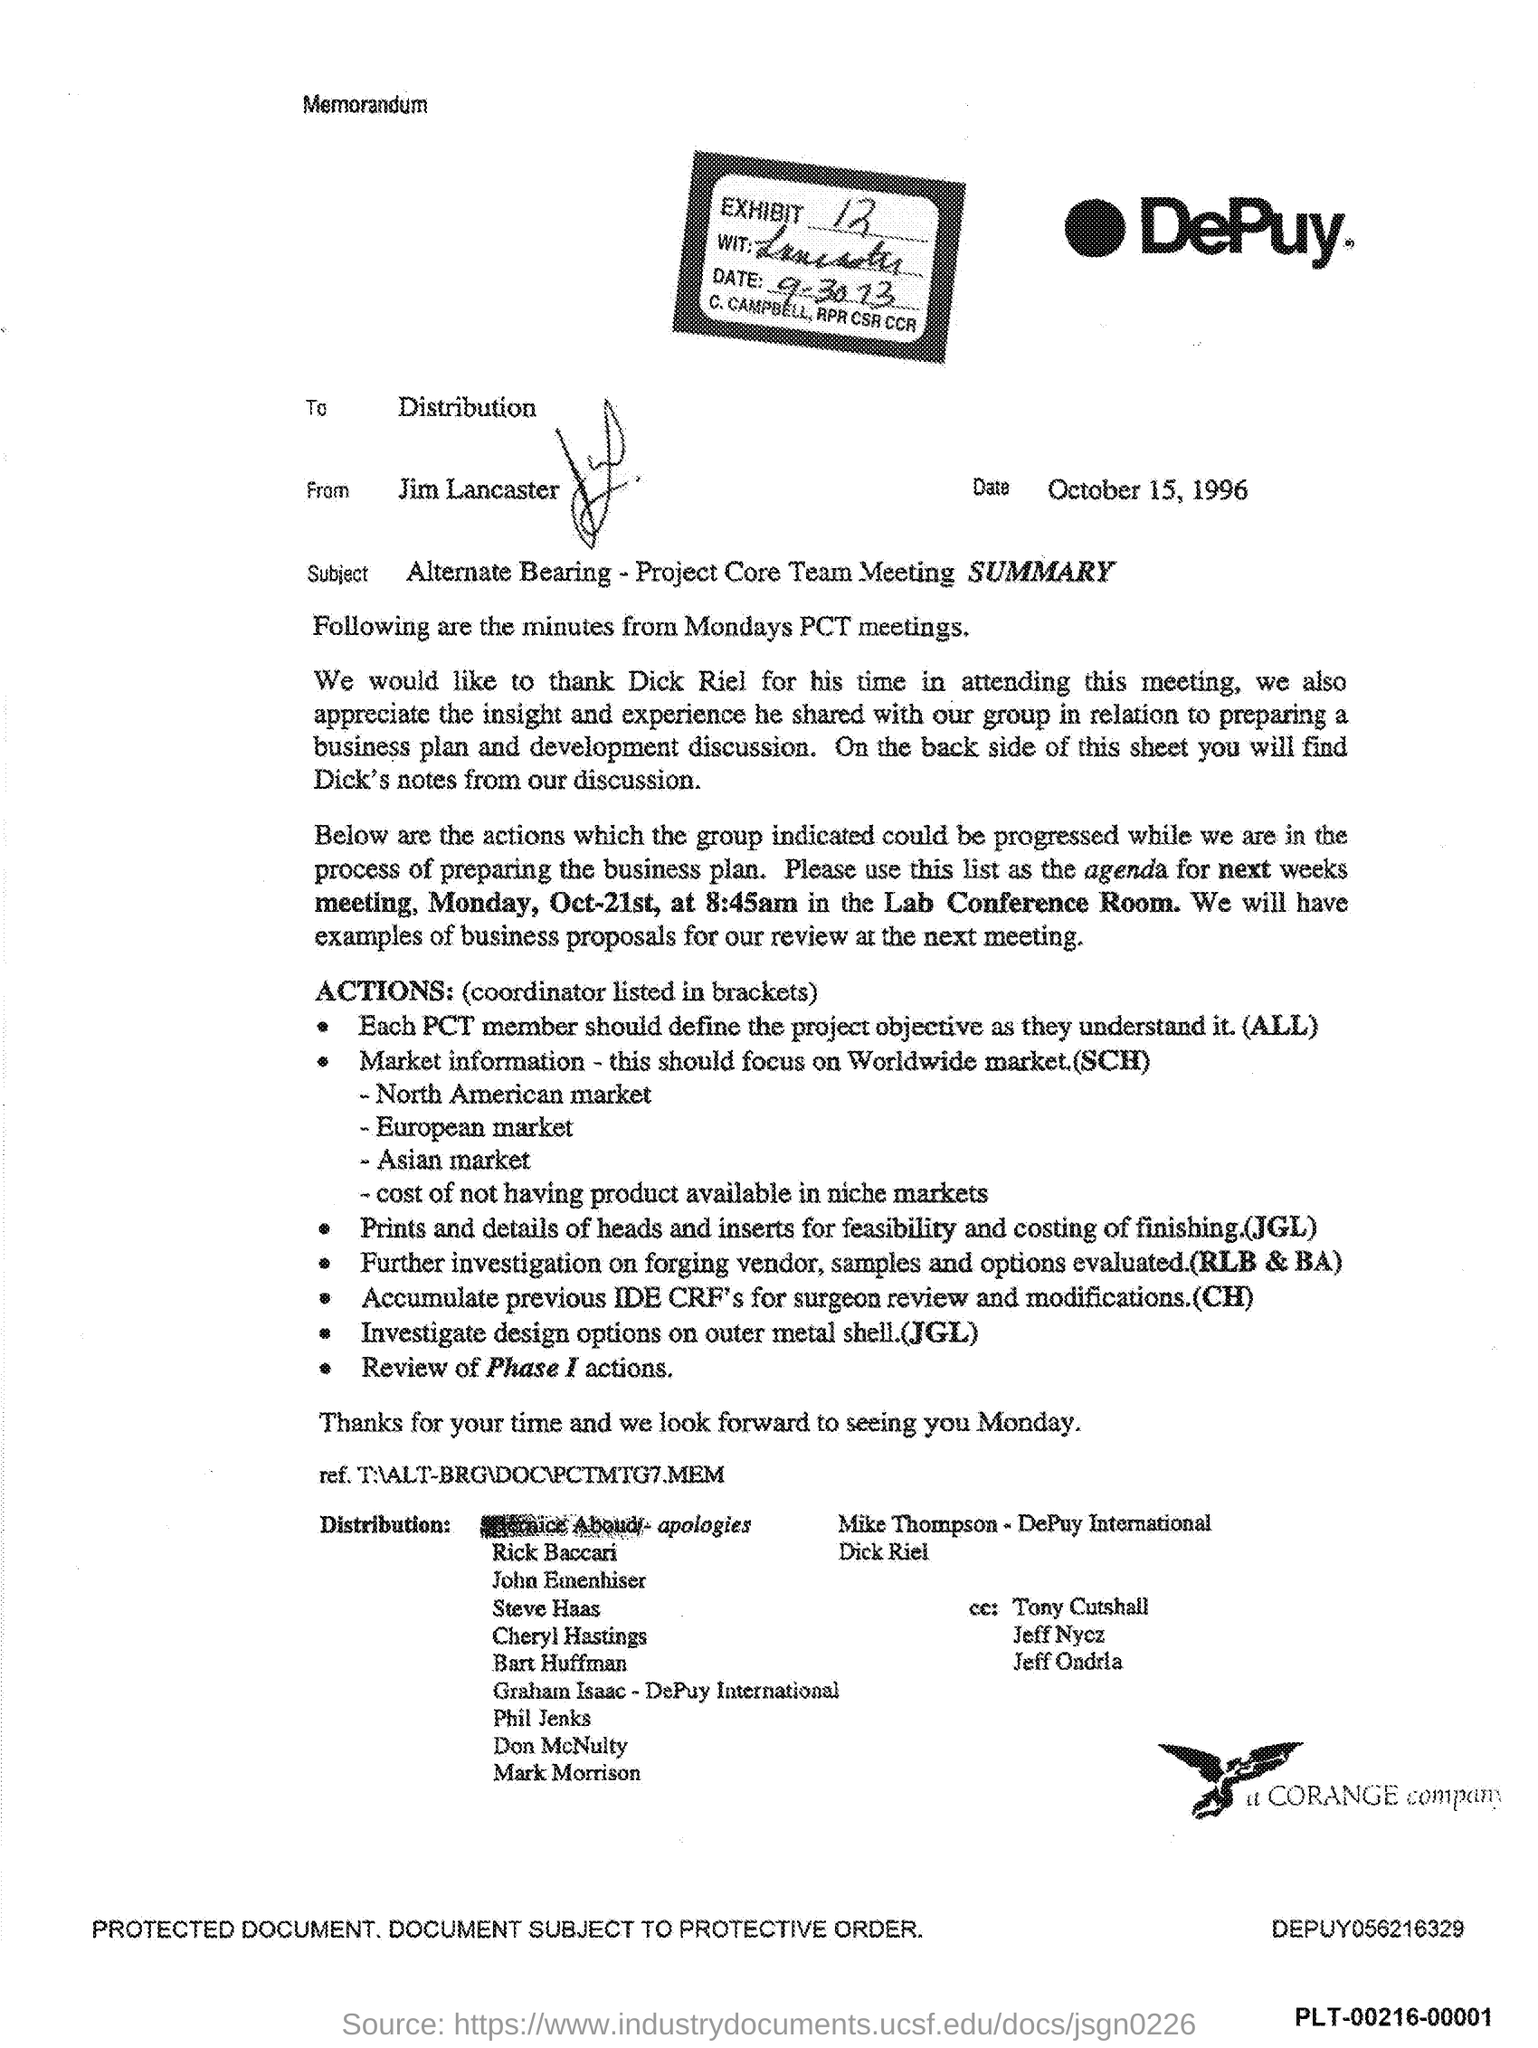Highlight a few significant elements in this photo. This memorandum concerns the subject of alternate bearing for the Project Core Team Meeting SUMMARY. The memorandum in question is from DePuy. This memorandum was issued on October 15, 1996. The memorandum indicates that Jim Lancaster is the sender. The memorandum did not mention an Exhibit No. 12. 